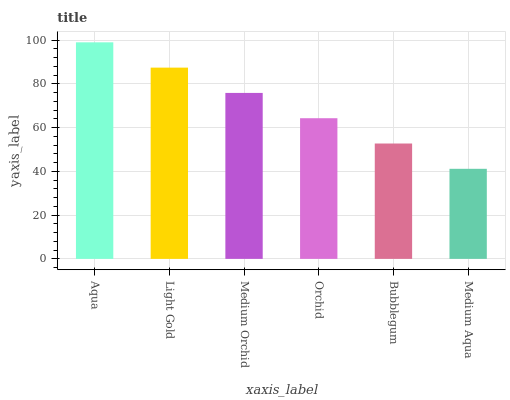Is Medium Aqua the minimum?
Answer yes or no. Yes. Is Aqua the maximum?
Answer yes or no. Yes. Is Light Gold the minimum?
Answer yes or no. No. Is Light Gold the maximum?
Answer yes or no. No. Is Aqua greater than Light Gold?
Answer yes or no. Yes. Is Light Gold less than Aqua?
Answer yes or no. Yes. Is Light Gold greater than Aqua?
Answer yes or no. No. Is Aqua less than Light Gold?
Answer yes or no. No. Is Medium Orchid the high median?
Answer yes or no. Yes. Is Orchid the low median?
Answer yes or no. Yes. Is Light Gold the high median?
Answer yes or no. No. Is Medium Aqua the low median?
Answer yes or no. No. 